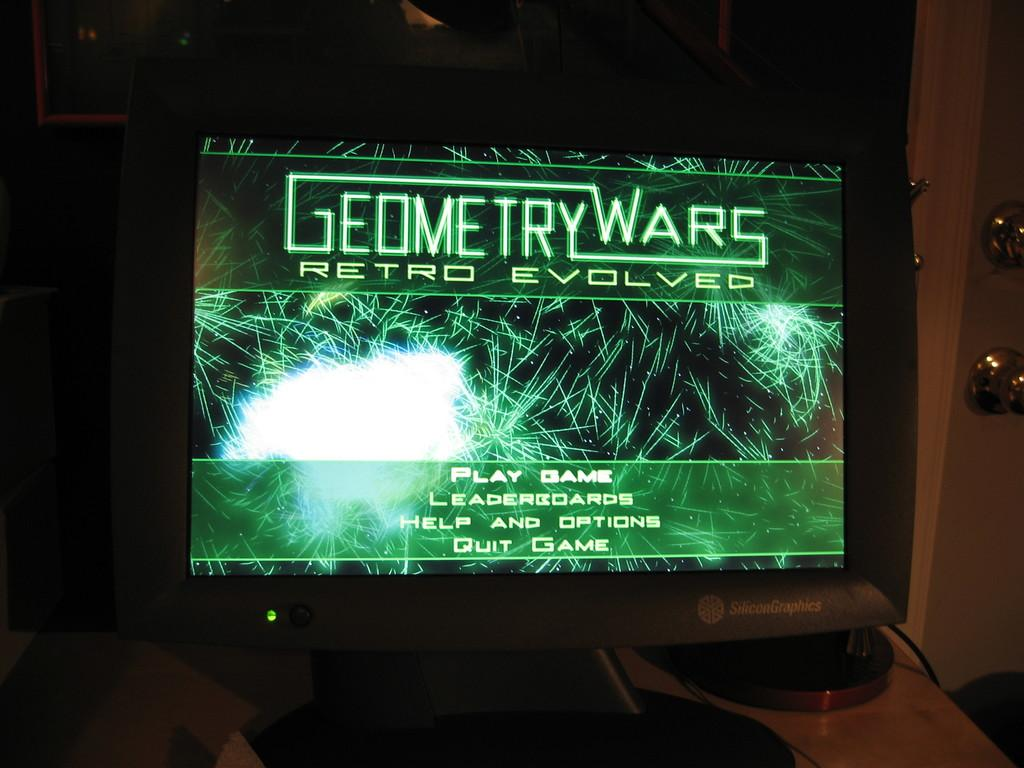<image>
Write a terse but informative summary of the picture. A Geometry Wars Retro Evolved game on a video screen 